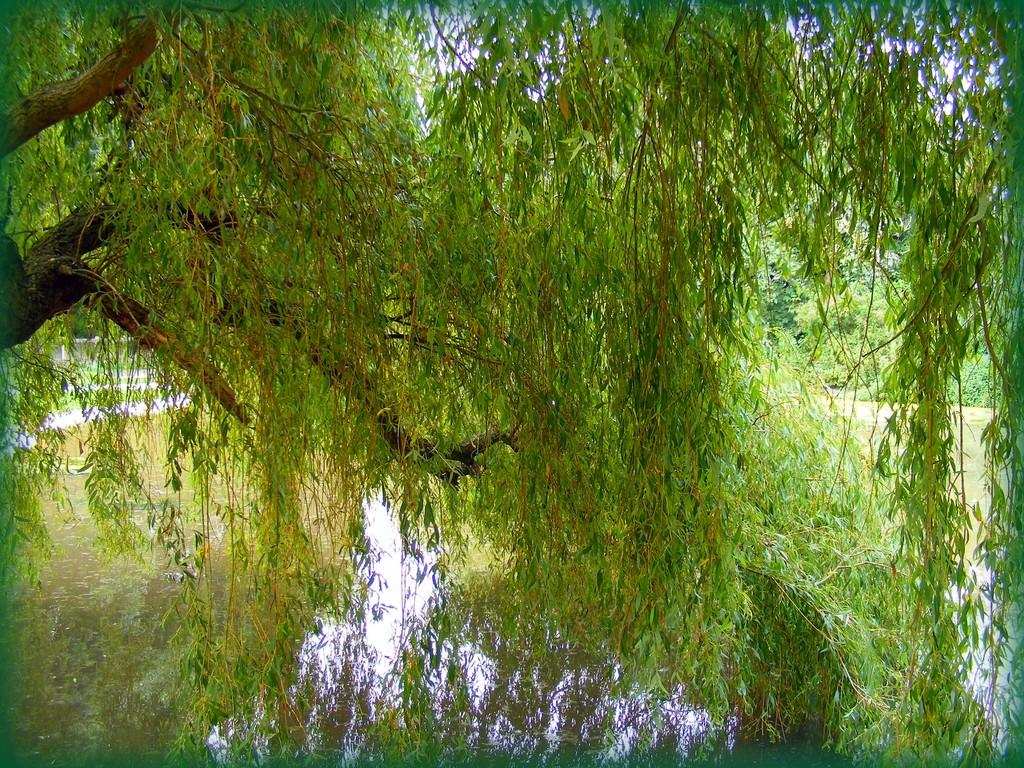What type of vegetation can be seen in the image? There are trees in the image. What natural element is visible in the image besides the trees? There is water visible in the image. What is the weight of the daughter in the image? There is no daughter present in the image, so it is not possible to determine her weight. 